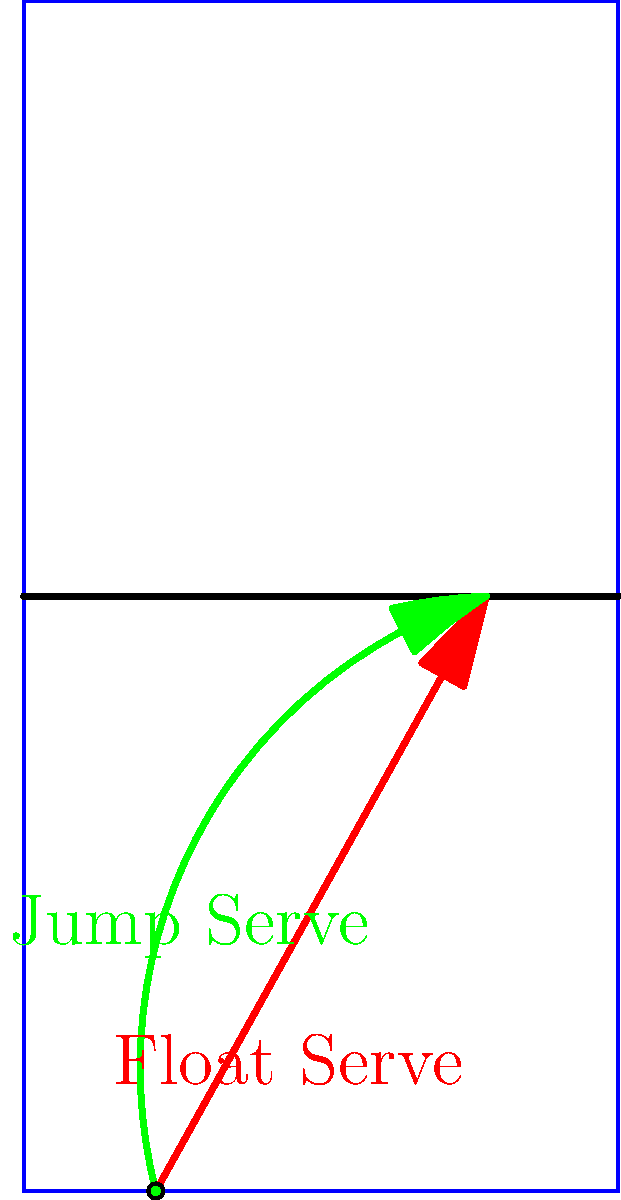In volleyball, the symmetrical properties of serve trajectories play a crucial role in deceiving opponents. Consider the float serve (red) and jump serve (green) trajectories shown in the diagram. Which serve trajectory exhibits rotational symmetry about the vertical axis at the center of the court, and how does this impact the effectiveness of the serve in international competitions? Let's analyze this step-by-step:

1) Rotational symmetry: An object has rotational symmetry if it looks the same after a certain amount of rotation.

2) Float serve (red trajectory):
   - The path is roughly parabolic and symmetrical.
   - If we rotate the court 180° around its vertical center axis, the float serve trajectory would look nearly identical.

3) Jump serve (green trajectory):
   - The path is more asymmetrical, with a steeper initial ascent.
   - If rotated 180° around the court's vertical center axis, it would look noticeably different.

4) Impact on effectiveness:
   - Float serve: Due to its symmetry, it's harder for receivers to predict its landing spot, making it more deceptive.
   - Jump serve: While less symmetrical, it compensates with higher speed and a steeper angle, making it challenging to receive.

5) In international competitions:
   - The float serve's symmetry allows servers to aim for any part of the court with a similar trajectory, keeping opponents guessing.
   - This unpredictability is particularly effective against top-tier teams who excel at reading serves.

Therefore, the float serve (red trajectory) exhibits rotational symmetry, enhancing its effectiveness by increasing unpredictability in high-level international matches.
Answer: Float serve; increases unpredictability 